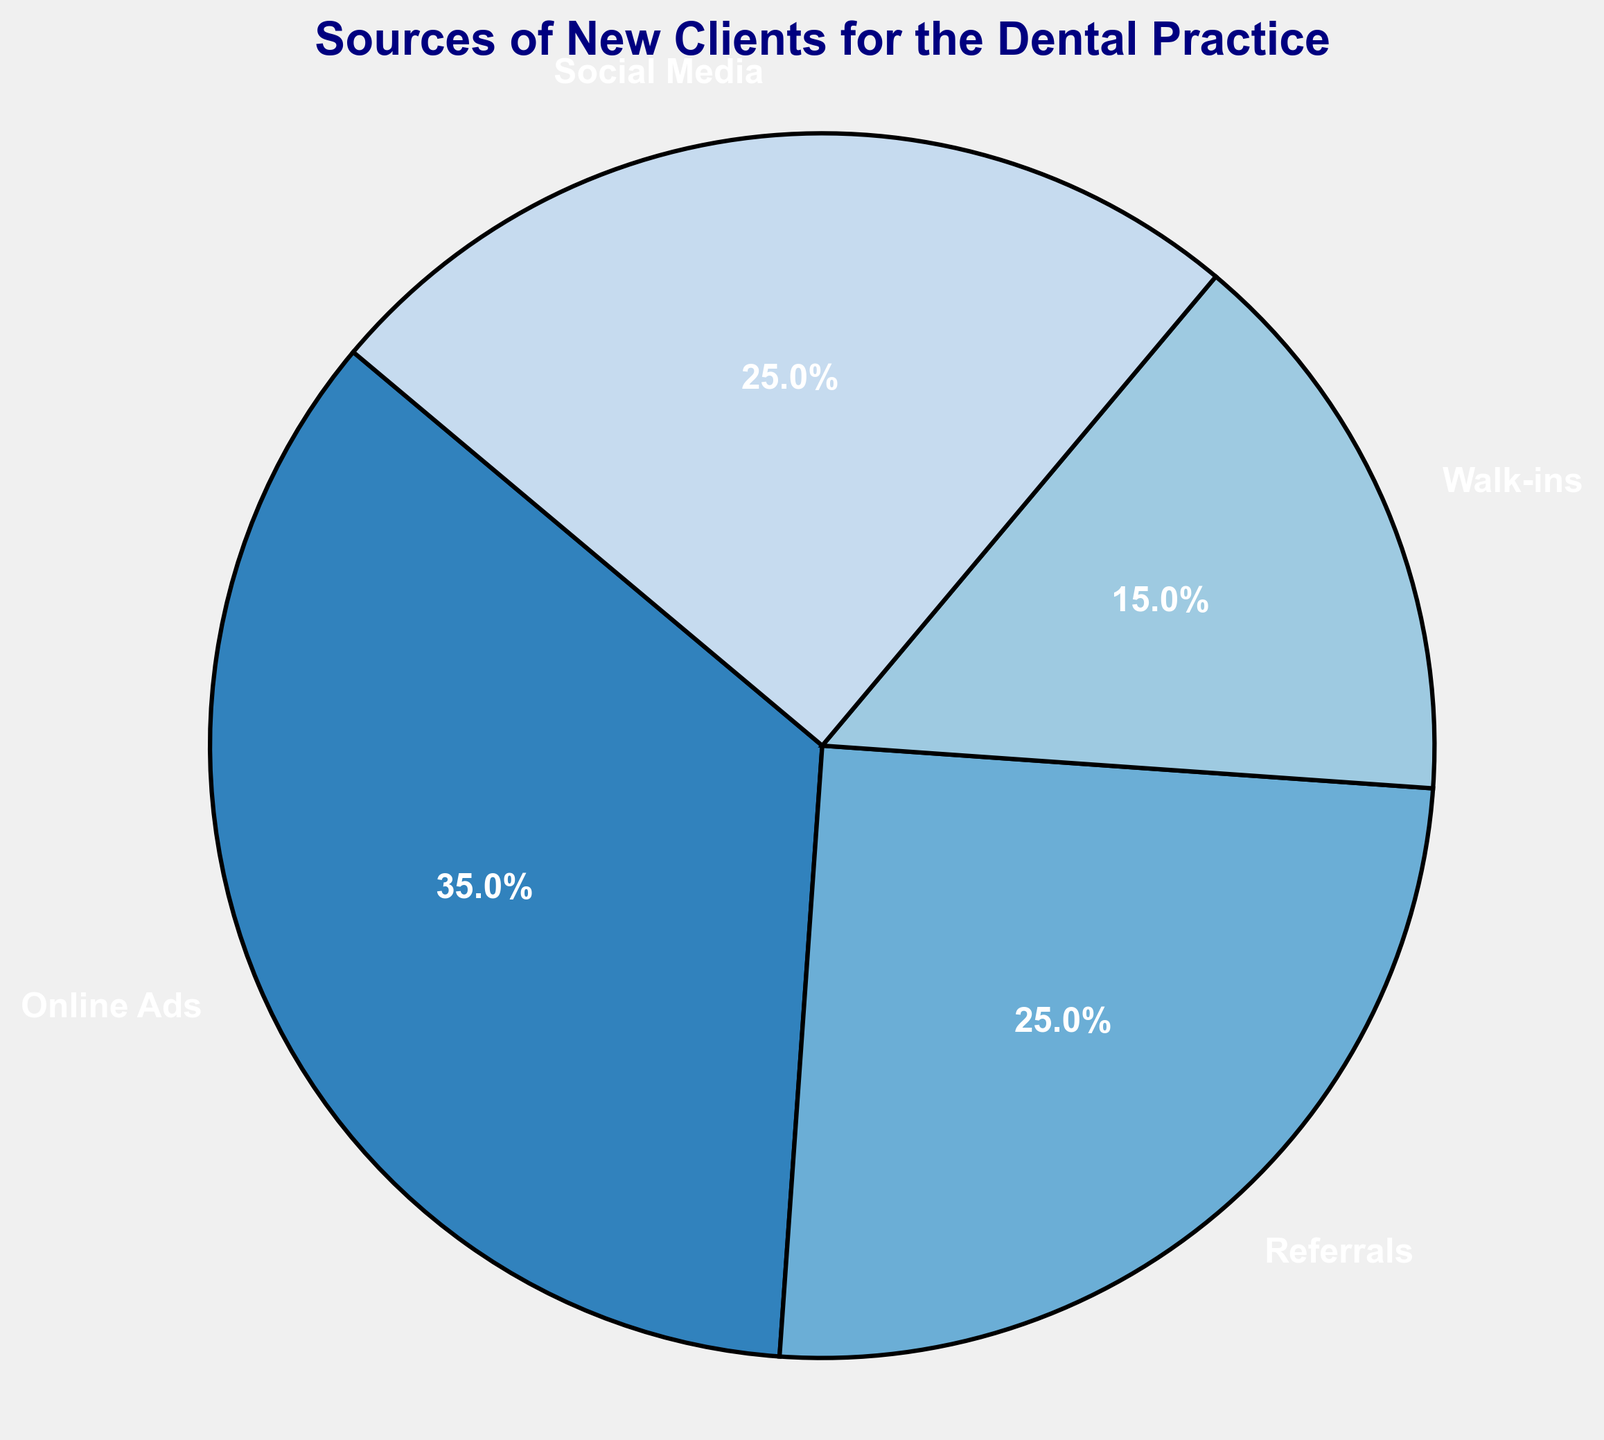What percentage of new clients came from online sources (combine Online Ads and Social Media)? From the chart, Online Ads account for 35% and Social Media accounts for 25%. Adding these percentages together gives 35% + 25% = 60%.
Answer: 60% Which source brought in the fewest new clients? From the chart, Walk-ins are represented by the smallest portion of the pie, which is 15%.
Answer: Walk-ins Are there any sources that contribute equally to new client acquisition? According to the chart, Referrals and Social Media each contribute 25%.
Answer: Yes, Referrals and Social Media By how much does the percentage of new clients from Online Ads exceed that from Walk-ins? From the chart, Online Ads make up 35%, and Walk-ins make up 15%. The difference is 35% - 15% = 20%.
Answer: 20% Is the combined percentage from Referrals and Social Media greater than the percentage from Online Ads? Referrals contribute 25%, and Social Media also contributes 25%. Their combined total is 25% + 25% = 50%. This is less than Online Ads' 35%.
Answer: No What fraction of the total new clients came from Referrals? Referrals account for 25% of the new clients. 25% of 100% is 1/4 or one-fourth.
Answer: 1/4 How does the percentage of new clients from Walk-ins compare to those from Social Media? Walk-ins make up 15% of new clients, while Social Media makes up 25%. Social Media's contribution (25%) is greater than Walk-ins' (15%).
Answer: Less What is the average percentage of new clients from each source? The total percentage from all sources is 100%. There are four sources. So, the average percentage is 100% / 4 = 25%.
Answer: 25% If we combine the percentages of Walk-ins and Referrals, would the total be more than the percentage of Online Ads? Walk-ins account for 15%, and Referrals account for 25%. Their combined total is 15% + 25% = 40%, which is greater than Online Ads' 35%.
Answer: Yes 